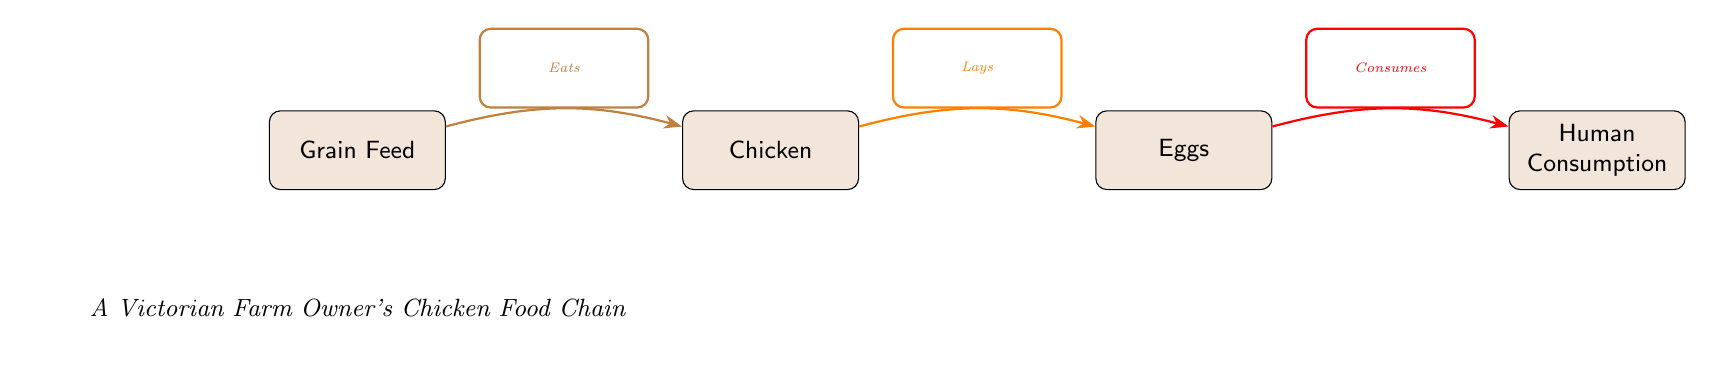What is the first node in the food chain? The first node in the food chain depicts the source of food for the chickens, which is "Grain Feed".
Answer: Grain Feed How many nodes are present in the diagram? The diagram displays four nodes: "Grain Feed", "Chicken", "Eggs", and "Human Consumption". Hence, the total count is four.
Answer: Four What does the chicken consume? According to the diagram, the chicken's diet consists of "Grain Feed" as indicated by the arrow labeled "Eats".
Answer: Grain Feed What are the eggs in relation to the chicken? The diagram shows that the eggs are produced by the chicken, with the relationship described by the arrow labeled "Lays".
Answer: Lays What is the final stage of the food chain? The last step in the food chain shown in the diagram leads to "Human Consumption", indicating what happens to the eggs.
Answer: Human Consumption What action connects “Chicken” and “Eggs”? The diagram specifies an action between these two nodes that is labeled "Lays", indicating how the chicken interacts with the eggs.
Answer: Lays What does the chicken eat to produce eggs? The diagram illustrates that chickens consume "Grain Feed", which is essential for them to later lay eggs.
Answer: Grain Feed What is the relationship between eggs and human consumption? The diagram indicates that the eggs are consumed by humans, demonstrated by the arrow labeled "Consumes".
Answer: Consumes Which node has a relationship labeled "Eats"? The arrow labeled "Eats" connects the "Grain Feed" node to the "Chicken" node, indicating that the chicken eats the grains.
Answer: Grain Feed 